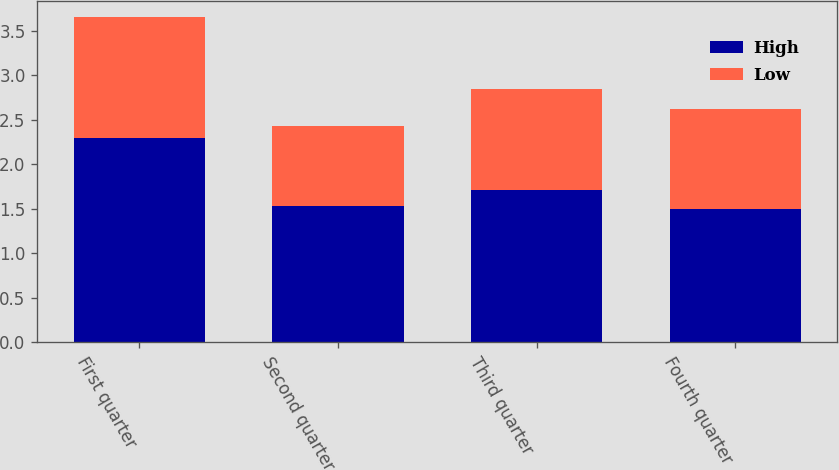Convert chart to OTSL. <chart><loc_0><loc_0><loc_500><loc_500><stacked_bar_chart><ecel><fcel>First quarter<fcel>Second quarter<fcel>Third quarter<fcel>Fourth quarter<nl><fcel>High<fcel>2.3<fcel>1.53<fcel>1.71<fcel>1.5<nl><fcel>Low<fcel>1.35<fcel>0.9<fcel>1.14<fcel>1.12<nl></chart> 